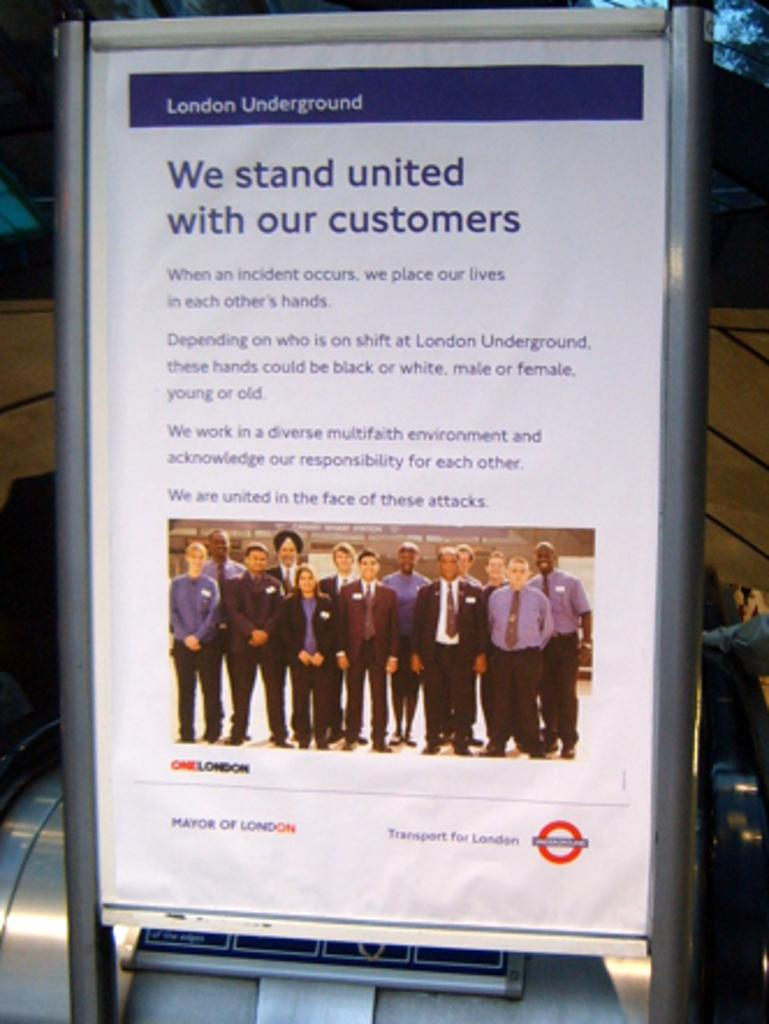<image>
Offer a succinct explanation of the picture presented. A London Underground sign with a short message about standing united with our customers. 